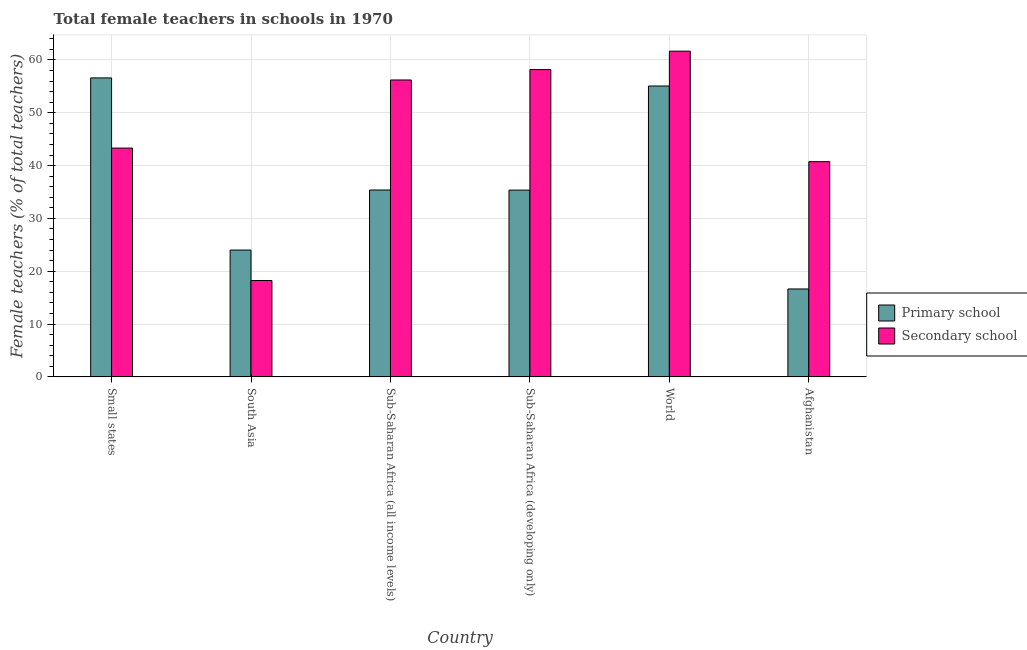How many groups of bars are there?
Make the answer very short. 6. Are the number of bars per tick equal to the number of legend labels?
Your answer should be compact. Yes. How many bars are there on the 2nd tick from the left?
Your answer should be very brief. 2. How many bars are there on the 5th tick from the right?
Make the answer very short. 2. What is the label of the 1st group of bars from the left?
Offer a very short reply. Small states. In how many cases, is the number of bars for a given country not equal to the number of legend labels?
Ensure brevity in your answer.  0. What is the percentage of female teachers in secondary schools in World?
Provide a short and direct response. 61.67. Across all countries, what is the maximum percentage of female teachers in secondary schools?
Provide a succinct answer. 61.67. Across all countries, what is the minimum percentage of female teachers in secondary schools?
Provide a succinct answer. 18.24. In which country was the percentage of female teachers in primary schools maximum?
Provide a short and direct response. Small states. In which country was the percentage of female teachers in secondary schools minimum?
Keep it short and to the point. South Asia. What is the total percentage of female teachers in primary schools in the graph?
Offer a very short reply. 223.06. What is the difference between the percentage of female teachers in primary schools in Afghanistan and that in Small states?
Your answer should be compact. -39.96. What is the difference between the percentage of female teachers in primary schools in Afghanistan and the percentage of female teachers in secondary schools in Sub-Saharan Africa (all income levels)?
Ensure brevity in your answer.  -39.57. What is the average percentage of female teachers in secondary schools per country?
Your answer should be compact. 46.39. What is the difference between the percentage of female teachers in primary schools and percentage of female teachers in secondary schools in Sub-Saharan Africa (developing only)?
Your answer should be compact. -22.83. In how many countries, is the percentage of female teachers in primary schools greater than 34 %?
Your answer should be very brief. 4. What is the ratio of the percentage of female teachers in primary schools in Afghanistan to that in Small states?
Make the answer very short. 0.29. Is the difference between the percentage of female teachers in primary schools in South Asia and Sub-Saharan Africa (all income levels) greater than the difference between the percentage of female teachers in secondary schools in South Asia and Sub-Saharan Africa (all income levels)?
Offer a terse response. Yes. What is the difference between the highest and the second highest percentage of female teachers in secondary schools?
Your answer should be compact. 3.48. What is the difference between the highest and the lowest percentage of female teachers in secondary schools?
Offer a terse response. 43.42. In how many countries, is the percentage of female teachers in primary schools greater than the average percentage of female teachers in primary schools taken over all countries?
Your response must be concise. 2. Is the sum of the percentage of female teachers in primary schools in Small states and World greater than the maximum percentage of female teachers in secondary schools across all countries?
Provide a succinct answer. Yes. What does the 1st bar from the left in World represents?
Make the answer very short. Primary school. What does the 2nd bar from the right in Small states represents?
Keep it short and to the point. Primary school. How many bars are there?
Provide a succinct answer. 12. How many countries are there in the graph?
Your answer should be compact. 6. What is the difference between two consecutive major ticks on the Y-axis?
Keep it short and to the point. 10. Are the values on the major ticks of Y-axis written in scientific E-notation?
Make the answer very short. No. Does the graph contain any zero values?
Ensure brevity in your answer.  No. How many legend labels are there?
Offer a terse response. 2. What is the title of the graph?
Keep it short and to the point. Total female teachers in schools in 1970. Does "Broad money growth" appear as one of the legend labels in the graph?
Provide a succinct answer. No. What is the label or title of the X-axis?
Offer a very short reply. Country. What is the label or title of the Y-axis?
Ensure brevity in your answer.  Female teachers (% of total teachers). What is the Female teachers (% of total teachers) in Primary school in Small states?
Provide a succinct answer. 56.6. What is the Female teachers (% of total teachers) of Secondary school in Small states?
Give a very brief answer. 43.32. What is the Female teachers (% of total teachers) in Primary school in South Asia?
Provide a succinct answer. 24.01. What is the Female teachers (% of total teachers) in Secondary school in South Asia?
Give a very brief answer. 18.24. What is the Female teachers (% of total teachers) in Primary school in Sub-Saharan Africa (all income levels)?
Your answer should be compact. 35.38. What is the Female teachers (% of total teachers) of Secondary school in Sub-Saharan Africa (all income levels)?
Give a very brief answer. 56.21. What is the Female teachers (% of total teachers) in Primary school in Sub-Saharan Africa (developing only)?
Provide a short and direct response. 35.36. What is the Female teachers (% of total teachers) of Secondary school in Sub-Saharan Africa (developing only)?
Provide a succinct answer. 58.18. What is the Female teachers (% of total teachers) in Primary school in World?
Offer a very short reply. 55.07. What is the Female teachers (% of total teachers) of Secondary school in World?
Make the answer very short. 61.67. What is the Female teachers (% of total teachers) of Primary school in Afghanistan?
Make the answer very short. 16.64. What is the Female teachers (% of total teachers) of Secondary school in Afghanistan?
Keep it short and to the point. 40.74. Across all countries, what is the maximum Female teachers (% of total teachers) of Primary school?
Provide a short and direct response. 56.6. Across all countries, what is the maximum Female teachers (% of total teachers) in Secondary school?
Provide a succinct answer. 61.67. Across all countries, what is the minimum Female teachers (% of total teachers) in Primary school?
Your response must be concise. 16.64. Across all countries, what is the minimum Female teachers (% of total teachers) of Secondary school?
Offer a very short reply. 18.24. What is the total Female teachers (% of total teachers) in Primary school in the graph?
Offer a terse response. 223.06. What is the total Female teachers (% of total teachers) in Secondary school in the graph?
Keep it short and to the point. 278.37. What is the difference between the Female teachers (% of total teachers) of Primary school in Small states and that in South Asia?
Your answer should be very brief. 32.59. What is the difference between the Female teachers (% of total teachers) in Secondary school in Small states and that in South Asia?
Offer a terse response. 25.07. What is the difference between the Female teachers (% of total teachers) of Primary school in Small states and that in Sub-Saharan Africa (all income levels)?
Your answer should be very brief. 21.22. What is the difference between the Female teachers (% of total teachers) in Secondary school in Small states and that in Sub-Saharan Africa (all income levels)?
Make the answer very short. -12.89. What is the difference between the Female teachers (% of total teachers) of Primary school in Small states and that in Sub-Saharan Africa (developing only)?
Ensure brevity in your answer.  21.24. What is the difference between the Female teachers (% of total teachers) of Secondary school in Small states and that in Sub-Saharan Africa (developing only)?
Make the answer very short. -14.87. What is the difference between the Female teachers (% of total teachers) in Primary school in Small states and that in World?
Your answer should be compact. 1.53. What is the difference between the Female teachers (% of total teachers) of Secondary school in Small states and that in World?
Offer a very short reply. -18.35. What is the difference between the Female teachers (% of total teachers) of Primary school in Small states and that in Afghanistan?
Your answer should be very brief. 39.96. What is the difference between the Female teachers (% of total teachers) in Secondary school in Small states and that in Afghanistan?
Give a very brief answer. 2.57. What is the difference between the Female teachers (% of total teachers) of Primary school in South Asia and that in Sub-Saharan Africa (all income levels)?
Provide a short and direct response. -11.37. What is the difference between the Female teachers (% of total teachers) in Secondary school in South Asia and that in Sub-Saharan Africa (all income levels)?
Your answer should be compact. -37.97. What is the difference between the Female teachers (% of total teachers) in Primary school in South Asia and that in Sub-Saharan Africa (developing only)?
Make the answer very short. -11.35. What is the difference between the Female teachers (% of total teachers) in Secondary school in South Asia and that in Sub-Saharan Africa (developing only)?
Provide a succinct answer. -39.94. What is the difference between the Female teachers (% of total teachers) of Primary school in South Asia and that in World?
Ensure brevity in your answer.  -31.06. What is the difference between the Female teachers (% of total teachers) in Secondary school in South Asia and that in World?
Give a very brief answer. -43.42. What is the difference between the Female teachers (% of total teachers) of Primary school in South Asia and that in Afghanistan?
Keep it short and to the point. 7.37. What is the difference between the Female teachers (% of total teachers) in Secondary school in South Asia and that in Afghanistan?
Offer a terse response. -22.5. What is the difference between the Female teachers (% of total teachers) of Primary school in Sub-Saharan Africa (all income levels) and that in Sub-Saharan Africa (developing only)?
Provide a short and direct response. 0.02. What is the difference between the Female teachers (% of total teachers) of Secondary school in Sub-Saharan Africa (all income levels) and that in Sub-Saharan Africa (developing only)?
Offer a terse response. -1.97. What is the difference between the Female teachers (% of total teachers) of Primary school in Sub-Saharan Africa (all income levels) and that in World?
Your response must be concise. -19.69. What is the difference between the Female teachers (% of total teachers) in Secondary school in Sub-Saharan Africa (all income levels) and that in World?
Keep it short and to the point. -5.46. What is the difference between the Female teachers (% of total teachers) in Primary school in Sub-Saharan Africa (all income levels) and that in Afghanistan?
Your answer should be compact. 18.74. What is the difference between the Female teachers (% of total teachers) in Secondary school in Sub-Saharan Africa (all income levels) and that in Afghanistan?
Your response must be concise. 15.47. What is the difference between the Female teachers (% of total teachers) in Primary school in Sub-Saharan Africa (developing only) and that in World?
Your answer should be very brief. -19.71. What is the difference between the Female teachers (% of total teachers) in Secondary school in Sub-Saharan Africa (developing only) and that in World?
Give a very brief answer. -3.48. What is the difference between the Female teachers (% of total teachers) of Primary school in Sub-Saharan Africa (developing only) and that in Afghanistan?
Make the answer very short. 18.71. What is the difference between the Female teachers (% of total teachers) in Secondary school in Sub-Saharan Africa (developing only) and that in Afghanistan?
Make the answer very short. 17.44. What is the difference between the Female teachers (% of total teachers) in Primary school in World and that in Afghanistan?
Make the answer very short. 38.43. What is the difference between the Female teachers (% of total teachers) of Secondary school in World and that in Afghanistan?
Make the answer very short. 20.92. What is the difference between the Female teachers (% of total teachers) in Primary school in Small states and the Female teachers (% of total teachers) in Secondary school in South Asia?
Your answer should be very brief. 38.36. What is the difference between the Female teachers (% of total teachers) in Primary school in Small states and the Female teachers (% of total teachers) in Secondary school in Sub-Saharan Africa (all income levels)?
Give a very brief answer. 0.39. What is the difference between the Female teachers (% of total teachers) of Primary school in Small states and the Female teachers (% of total teachers) of Secondary school in Sub-Saharan Africa (developing only)?
Offer a very short reply. -1.58. What is the difference between the Female teachers (% of total teachers) in Primary school in Small states and the Female teachers (% of total teachers) in Secondary school in World?
Your answer should be very brief. -5.07. What is the difference between the Female teachers (% of total teachers) of Primary school in Small states and the Female teachers (% of total teachers) of Secondary school in Afghanistan?
Offer a terse response. 15.86. What is the difference between the Female teachers (% of total teachers) in Primary school in South Asia and the Female teachers (% of total teachers) in Secondary school in Sub-Saharan Africa (all income levels)?
Your answer should be compact. -32.2. What is the difference between the Female teachers (% of total teachers) of Primary school in South Asia and the Female teachers (% of total teachers) of Secondary school in Sub-Saharan Africa (developing only)?
Keep it short and to the point. -34.17. What is the difference between the Female teachers (% of total teachers) in Primary school in South Asia and the Female teachers (% of total teachers) in Secondary school in World?
Give a very brief answer. -37.66. What is the difference between the Female teachers (% of total teachers) of Primary school in South Asia and the Female teachers (% of total teachers) of Secondary school in Afghanistan?
Provide a succinct answer. -16.73. What is the difference between the Female teachers (% of total teachers) in Primary school in Sub-Saharan Africa (all income levels) and the Female teachers (% of total teachers) in Secondary school in Sub-Saharan Africa (developing only)?
Provide a short and direct response. -22.81. What is the difference between the Female teachers (% of total teachers) of Primary school in Sub-Saharan Africa (all income levels) and the Female teachers (% of total teachers) of Secondary school in World?
Make the answer very short. -26.29. What is the difference between the Female teachers (% of total teachers) in Primary school in Sub-Saharan Africa (all income levels) and the Female teachers (% of total teachers) in Secondary school in Afghanistan?
Keep it short and to the point. -5.36. What is the difference between the Female teachers (% of total teachers) of Primary school in Sub-Saharan Africa (developing only) and the Female teachers (% of total teachers) of Secondary school in World?
Your answer should be compact. -26.31. What is the difference between the Female teachers (% of total teachers) of Primary school in Sub-Saharan Africa (developing only) and the Female teachers (% of total teachers) of Secondary school in Afghanistan?
Make the answer very short. -5.39. What is the difference between the Female teachers (% of total teachers) of Primary school in World and the Female teachers (% of total teachers) of Secondary school in Afghanistan?
Keep it short and to the point. 14.33. What is the average Female teachers (% of total teachers) in Primary school per country?
Your answer should be very brief. 37.18. What is the average Female teachers (% of total teachers) of Secondary school per country?
Provide a succinct answer. 46.39. What is the difference between the Female teachers (% of total teachers) of Primary school and Female teachers (% of total teachers) of Secondary school in Small states?
Your answer should be very brief. 13.28. What is the difference between the Female teachers (% of total teachers) in Primary school and Female teachers (% of total teachers) in Secondary school in South Asia?
Ensure brevity in your answer.  5.77. What is the difference between the Female teachers (% of total teachers) of Primary school and Female teachers (% of total teachers) of Secondary school in Sub-Saharan Africa (all income levels)?
Provide a short and direct response. -20.83. What is the difference between the Female teachers (% of total teachers) of Primary school and Female teachers (% of total teachers) of Secondary school in Sub-Saharan Africa (developing only)?
Provide a succinct answer. -22.83. What is the difference between the Female teachers (% of total teachers) in Primary school and Female teachers (% of total teachers) in Secondary school in World?
Keep it short and to the point. -6.6. What is the difference between the Female teachers (% of total teachers) in Primary school and Female teachers (% of total teachers) in Secondary school in Afghanistan?
Offer a terse response. -24.1. What is the ratio of the Female teachers (% of total teachers) in Primary school in Small states to that in South Asia?
Offer a terse response. 2.36. What is the ratio of the Female teachers (% of total teachers) of Secondary school in Small states to that in South Asia?
Give a very brief answer. 2.37. What is the ratio of the Female teachers (% of total teachers) in Primary school in Small states to that in Sub-Saharan Africa (all income levels)?
Ensure brevity in your answer.  1.6. What is the ratio of the Female teachers (% of total teachers) of Secondary school in Small states to that in Sub-Saharan Africa (all income levels)?
Keep it short and to the point. 0.77. What is the ratio of the Female teachers (% of total teachers) of Primary school in Small states to that in Sub-Saharan Africa (developing only)?
Ensure brevity in your answer.  1.6. What is the ratio of the Female teachers (% of total teachers) in Secondary school in Small states to that in Sub-Saharan Africa (developing only)?
Ensure brevity in your answer.  0.74. What is the ratio of the Female teachers (% of total teachers) of Primary school in Small states to that in World?
Offer a very short reply. 1.03. What is the ratio of the Female teachers (% of total teachers) in Secondary school in Small states to that in World?
Provide a succinct answer. 0.7. What is the ratio of the Female teachers (% of total teachers) of Primary school in Small states to that in Afghanistan?
Make the answer very short. 3.4. What is the ratio of the Female teachers (% of total teachers) of Secondary school in Small states to that in Afghanistan?
Your response must be concise. 1.06. What is the ratio of the Female teachers (% of total teachers) of Primary school in South Asia to that in Sub-Saharan Africa (all income levels)?
Provide a succinct answer. 0.68. What is the ratio of the Female teachers (% of total teachers) of Secondary school in South Asia to that in Sub-Saharan Africa (all income levels)?
Your answer should be very brief. 0.32. What is the ratio of the Female teachers (% of total teachers) of Primary school in South Asia to that in Sub-Saharan Africa (developing only)?
Your answer should be very brief. 0.68. What is the ratio of the Female teachers (% of total teachers) of Secondary school in South Asia to that in Sub-Saharan Africa (developing only)?
Offer a very short reply. 0.31. What is the ratio of the Female teachers (% of total teachers) in Primary school in South Asia to that in World?
Keep it short and to the point. 0.44. What is the ratio of the Female teachers (% of total teachers) of Secondary school in South Asia to that in World?
Provide a succinct answer. 0.3. What is the ratio of the Female teachers (% of total teachers) of Primary school in South Asia to that in Afghanistan?
Offer a very short reply. 1.44. What is the ratio of the Female teachers (% of total teachers) in Secondary school in South Asia to that in Afghanistan?
Give a very brief answer. 0.45. What is the ratio of the Female teachers (% of total teachers) in Secondary school in Sub-Saharan Africa (all income levels) to that in Sub-Saharan Africa (developing only)?
Your answer should be compact. 0.97. What is the ratio of the Female teachers (% of total teachers) of Primary school in Sub-Saharan Africa (all income levels) to that in World?
Make the answer very short. 0.64. What is the ratio of the Female teachers (% of total teachers) of Secondary school in Sub-Saharan Africa (all income levels) to that in World?
Make the answer very short. 0.91. What is the ratio of the Female teachers (% of total teachers) of Primary school in Sub-Saharan Africa (all income levels) to that in Afghanistan?
Offer a very short reply. 2.13. What is the ratio of the Female teachers (% of total teachers) in Secondary school in Sub-Saharan Africa (all income levels) to that in Afghanistan?
Your response must be concise. 1.38. What is the ratio of the Female teachers (% of total teachers) of Primary school in Sub-Saharan Africa (developing only) to that in World?
Provide a succinct answer. 0.64. What is the ratio of the Female teachers (% of total teachers) of Secondary school in Sub-Saharan Africa (developing only) to that in World?
Ensure brevity in your answer.  0.94. What is the ratio of the Female teachers (% of total teachers) in Primary school in Sub-Saharan Africa (developing only) to that in Afghanistan?
Offer a very short reply. 2.12. What is the ratio of the Female teachers (% of total teachers) in Secondary school in Sub-Saharan Africa (developing only) to that in Afghanistan?
Your answer should be very brief. 1.43. What is the ratio of the Female teachers (% of total teachers) in Primary school in World to that in Afghanistan?
Your answer should be compact. 3.31. What is the ratio of the Female teachers (% of total teachers) of Secondary school in World to that in Afghanistan?
Offer a terse response. 1.51. What is the difference between the highest and the second highest Female teachers (% of total teachers) of Primary school?
Offer a terse response. 1.53. What is the difference between the highest and the second highest Female teachers (% of total teachers) of Secondary school?
Provide a short and direct response. 3.48. What is the difference between the highest and the lowest Female teachers (% of total teachers) in Primary school?
Offer a terse response. 39.96. What is the difference between the highest and the lowest Female teachers (% of total teachers) in Secondary school?
Offer a terse response. 43.42. 